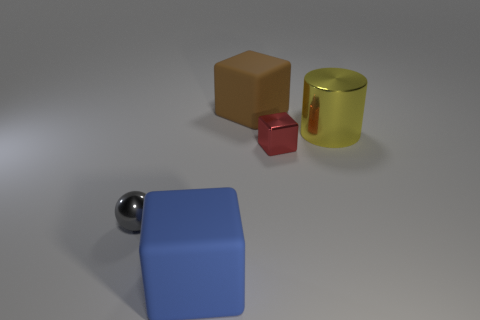Are there any other things that have the same shape as the gray shiny object?
Your answer should be very brief. No. Do the brown thing and the blue thing have the same size?
Keep it short and to the point. Yes. What material is the large cube in front of the big thing on the right side of the block that is behind the tiny block?
Ensure brevity in your answer.  Rubber. Are there the same number of large yellow things on the left side of the brown rubber thing and gray matte balls?
Offer a very short reply. Yes. What number of objects are either large gray objects or yellow metallic cylinders?
Your response must be concise. 1. There is a large blue thing that is made of the same material as the brown thing; what shape is it?
Offer a terse response. Cube. There is a matte cube to the left of the large cube behind the blue block; how big is it?
Provide a short and direct response. Large. What number of tiny things are either brown matte things or blue metallic cylinders?
Make the answer very short. 0. How many other things are the same color as the metal sphere?
Provide a succinct answer. 0. Does the matte thing behind the large yellow cylinder have the same size as the matte block that is in front of the yellow cylinder?
Your answer should be compact. Yes. 